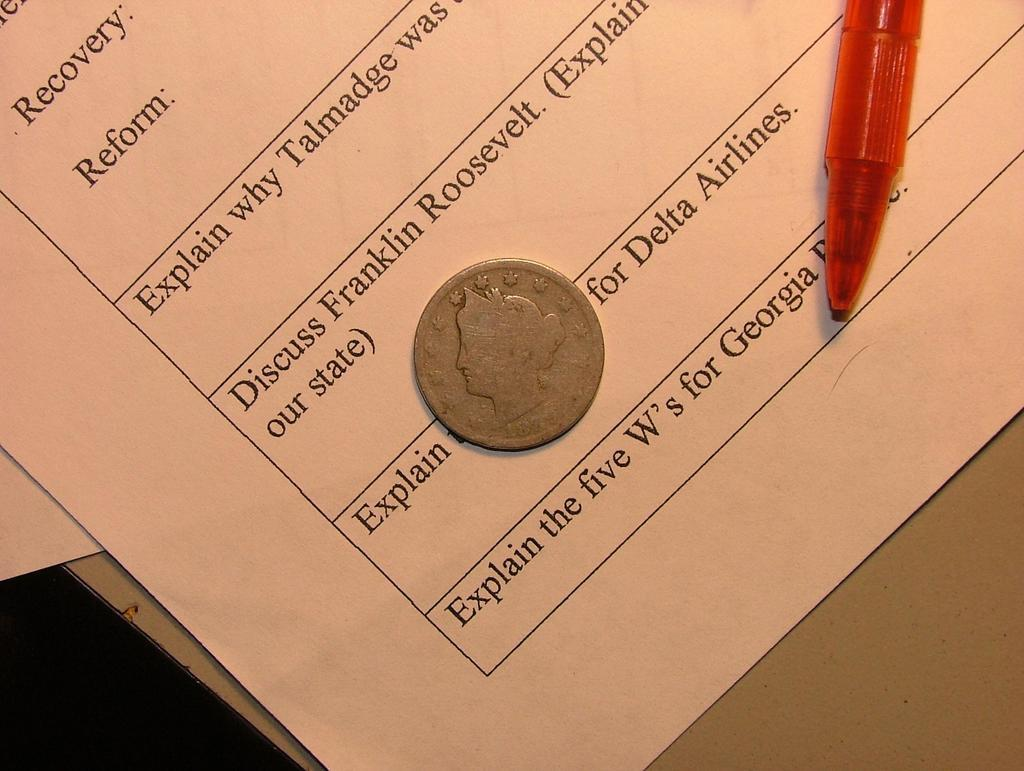What object can be seen on the table in the image? There is a coin on the table. What else is on the table besides the coin? There is paper and a pen on the table. What type of suit is the lawyer wearing in the image? There is no lawyer or suit present in the image; it only features a coin, paper, and a pen on the table. 